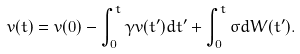<formula> <loc_0><loc_0><loc_500><loc_500>v ( t ) = v ( 0 ) - \int _ { 0 } ^ { t } \gamma v ( t ^ { \prime } ) d t ^ { \prime } + \int _ { 0 } ^ { t } \sigma d W ( t ^ { \prime } ) .</formula> 